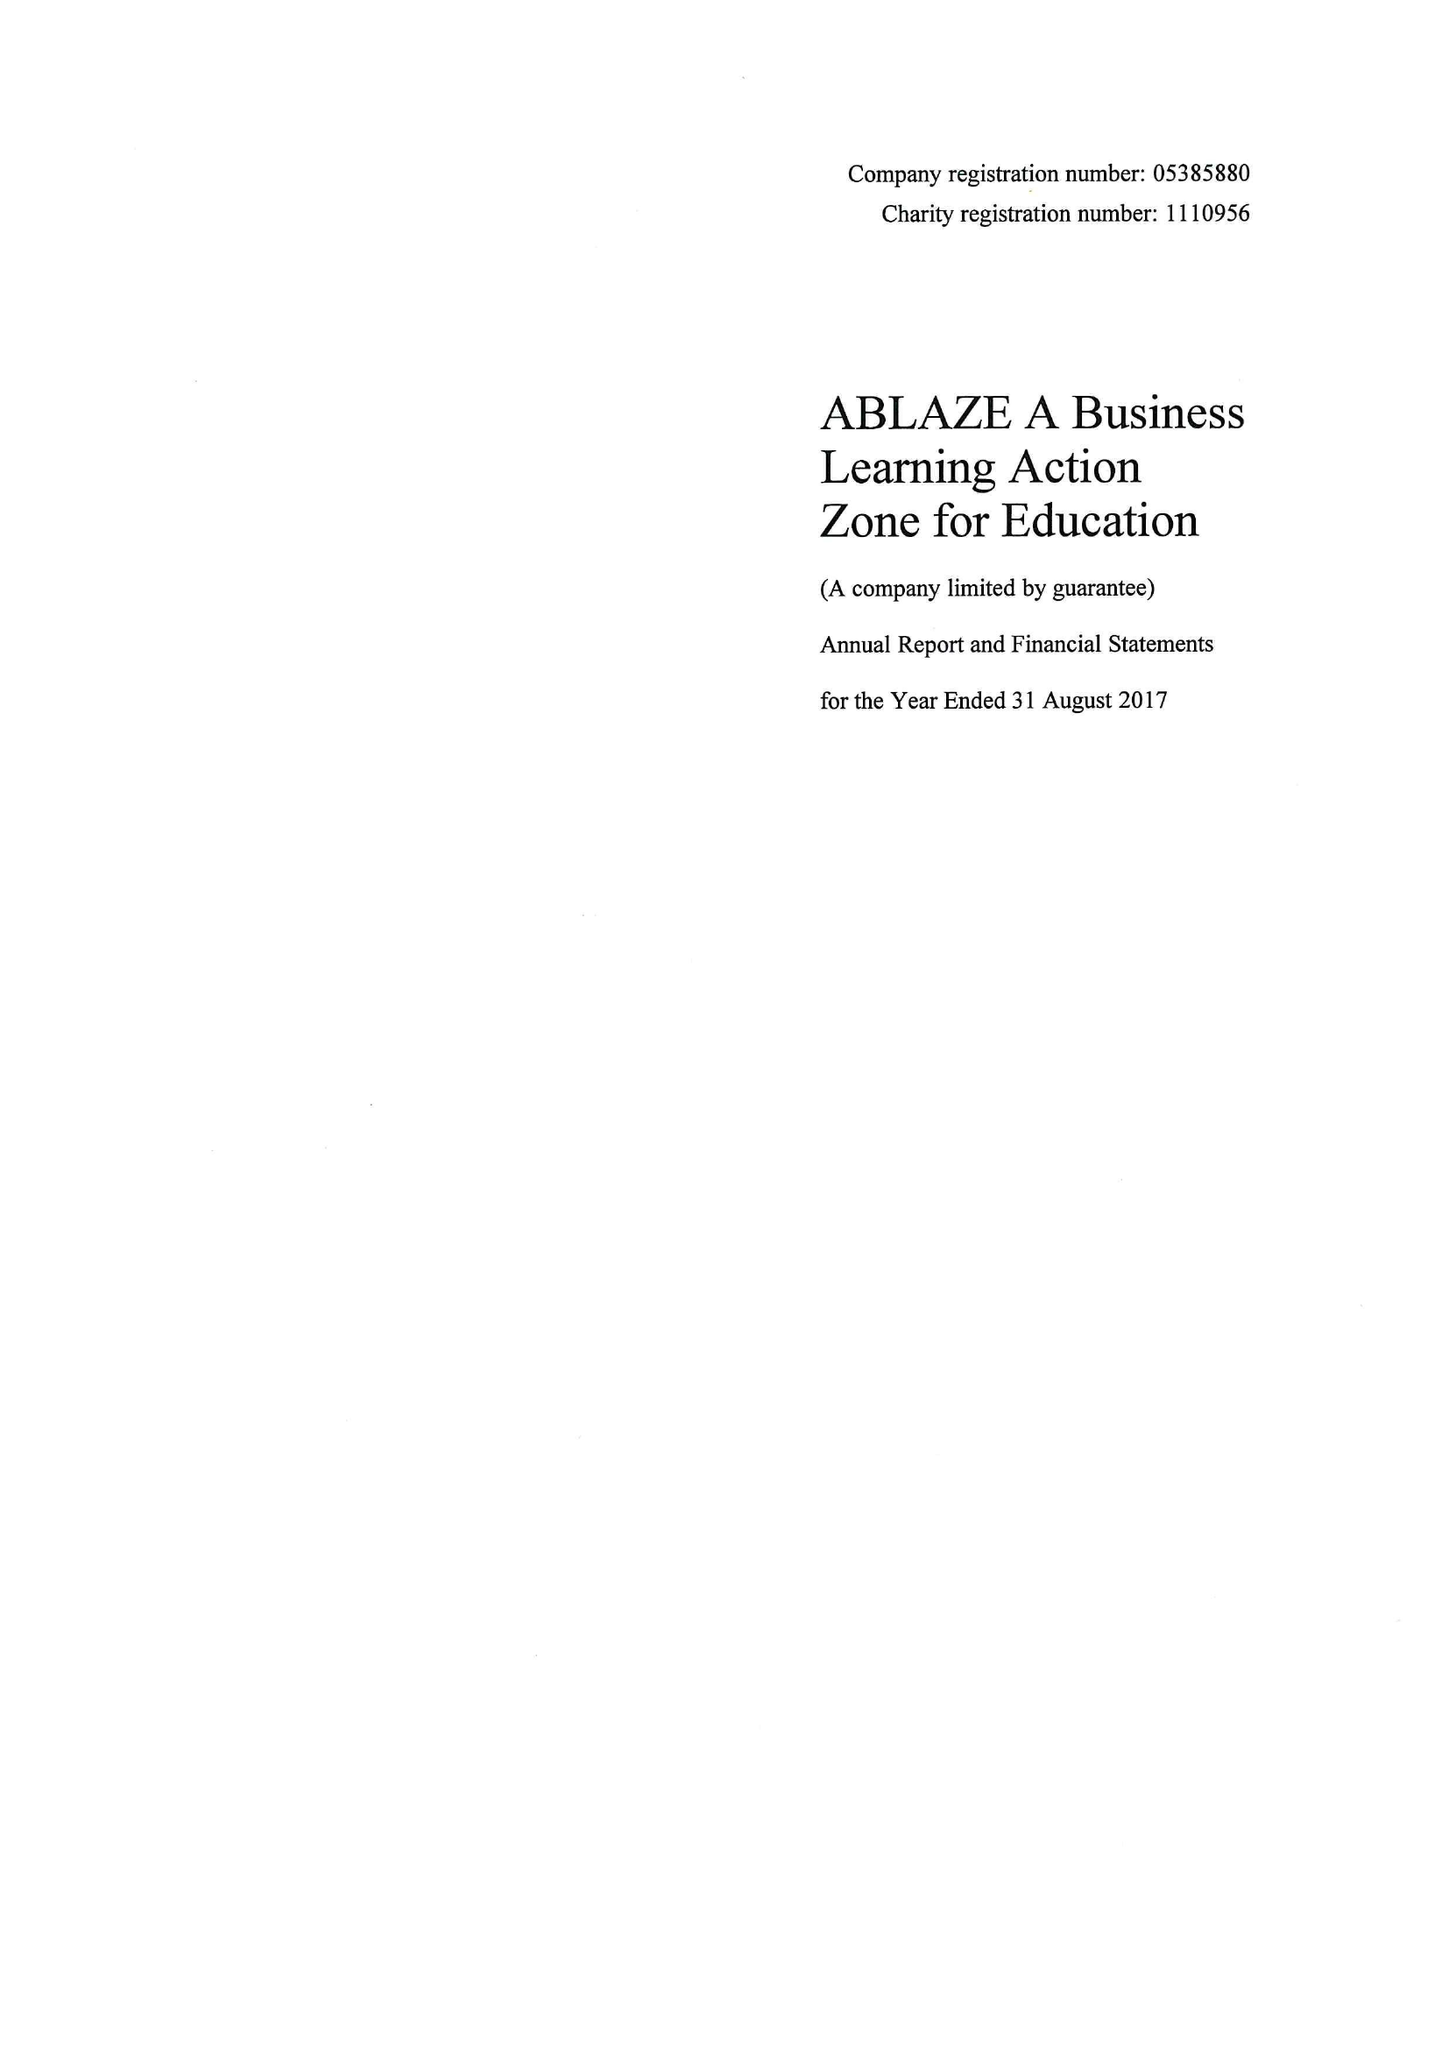What is the value for the spending_annually_in_british_pounds?
Answer the question using a single word or phrase. 109194.00 